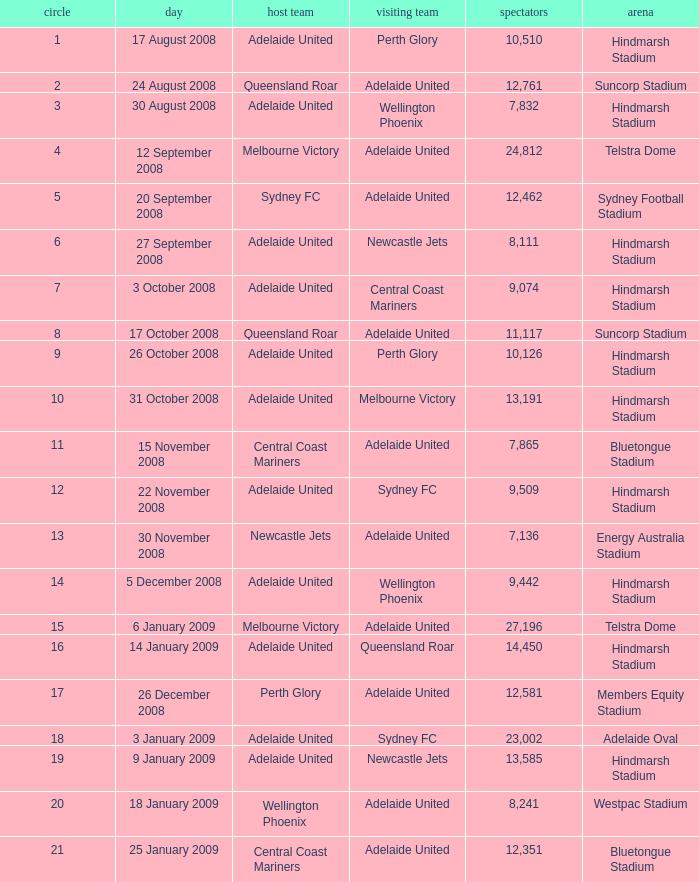Who was the away team when Queensland Roar was the home team in the round less than 3? Adelaide United. Would you mind parsing the complete table? {'header': ['circle', 'day', 'host team', 'visiting team', 'spectators', 'arena'], 'rows': [['1', '17 August 2008', 'Adelaide United', 'Perth Glory', '10,510', 'Hindmarsh Stadium'], ['2', '24 August 2008', 'Queensland Roar', 'Adelaide United', '12,761', 'Suncorp Stadium'], ['3', '30 August 2008', 'Adelaide United', 'Wellington Phoenix', '7,832', 'Hindmarsh Stadium'], ['4', '12 September 2008', 'Melbourne Victory', 'Adelaide United', '24,812', 'Telstra Dome'], ['5', '20 September 2008', 'Sydney FC', 'Adelaide United', '12,462', 'Sydney Football Stadium'], ['6', '27 September 2008', 'Adelaide United', 'Newcastle Jets', '8,111', 'Hindmarsh Stadium'], ['7', '3 October 2008', 'Adelaide United', 'Central Coast Mariners', '9,074', 'Hindmarsh Stadium'], ['8', '17 October 2008', 'Queensland Roar', 'Adelaide United', '11,117', 'Suncorp Stadium'], ['9', '26 October 2008', 'Adelaide United', 'Perth Glory', '10,126', 'Hindmarsh Stadium'], ['10', '31 October 2008', 'Adelaide United', 'Melbourne Victory', '13,191', 'Hindmarsh Stadium'], ['11', '15 November 2008', 'Central Coast Mariners', 'Adelaide United', '7,865', 'Bluetongue Stadium'], ['12', '22 November 2008', 'Adelaide United', 'Sydney FC', '9,509', 'Hindmarsh Stadium'], ['13', '30 November 2008', 'Newcastle Jets', 'Adelaide United', '7,136', 'Energy Australia Stadium'], ['14', '5 December 2008', 'Adelaide United', 'Wellington Phoenix', '9,442', 'Hindmarsh Stadium'], ['15', '6 January 2009', 'Melbourne Victory', 'Adelaide United', '27,196', 'Telstra Dome'], ['16', '14 January 2009', 'Adelaide United', 'Queensland Roar', '14,450', 'Hindmarsh Stadium'], ['17', '26 December 2008', 'Perth Glory', 'Adelaide United', '12,581', 'Members Equity Stadium'], ['18', '3 January 2009', 'Adelaide United', 'Sydney FC', '23,002', 'Adelaide Oval'], ['19', '9 January 2009', 'Adelaide United', 'Newcastle Jets', '13,585', 'Hindmarsh Stadium'], ['20', '18 January 2009', 'Wellington Phoenix', 'Adelaide United', '8,241', 'Westpac Stadium'], ['21', '25 January 2009', 'Central Coast Mariners', 'Adelaide United', '12,351', 'Bluetongue Stadium']]} 